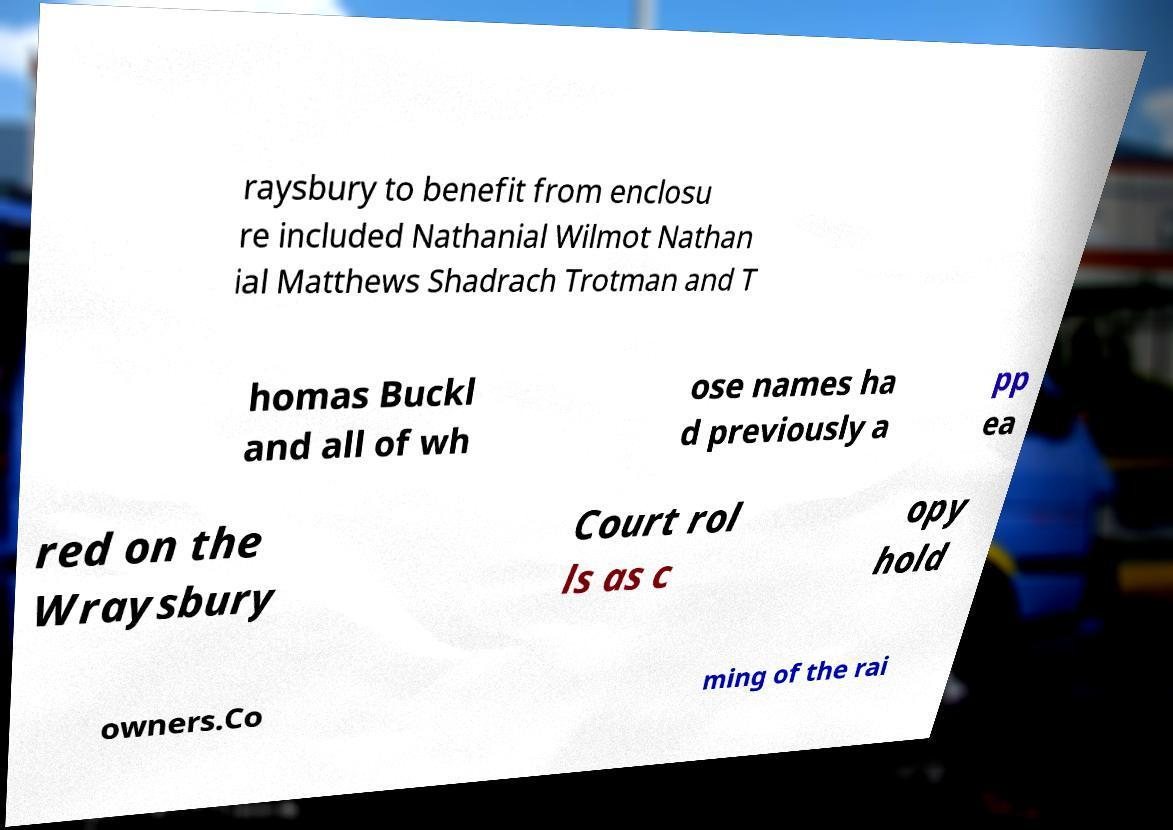What messages or text are displayed in this image? I need them in a readable, typed format. raysbury to benefit from enclosu re included Nathanial Wilmot Nathan ial Matthews Shadrach Trotman and T homas Buckl and all of wh ose names ha d previously a pp ea red on the Wraysbury Court rol ls as c opy hold owners.Co ming of the rai 